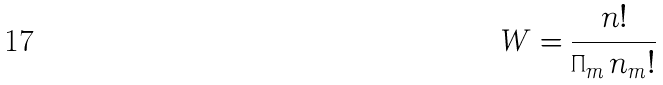Convert formula to latex. <formula><loc_0><loc_0><loc_500><loc_500>W = \frac { n ! } { \prod _ { m } n _ { m } ! }</formula> 